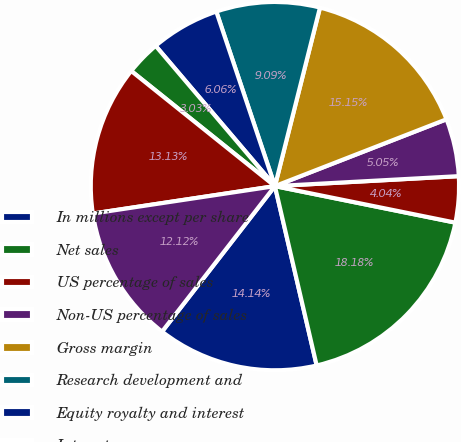Convert chart. <chart><loc_0><loc_0><loc_500><loc_500><pie_chart><fcel>In millions except per share<fcel>Net sales<fcel>US percentage of sales<fcel>Non-US percentage of sales<fcel>Gross margin<fcel>Research development and<fcel>Equity royalty and interest<fcel>Interest expense<fcel>Consolidated net income(1)<fcel>Net income attributable to<nl><fcel>14.14%<fcel>18.18%<fcel>4.04%<fcel>5.05%<fcel>15.15%<fcel>9.09%<fcel>6.06%<fcel>3.03%<fcel>13.13%<fcel>12.12%<nl></chart> 